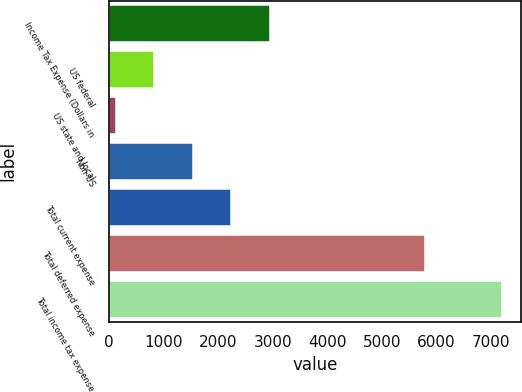<chart> <loc_0><loc_0><loc_500><loc_500><bar_chart><fcel>Income Tax Expense (Dollars in<fcel>US federal<fcel>US state and local<fcel>Non-US<fcel>Total current expense<fcel>Total deferred expense<fcel>Total income tax expense<nl><fcel>2951.6<fcel>827.9<fcel>120<fcel>1535.8<fcel>2243.7<fcel>5793<fcel>7199<nl></chart> 